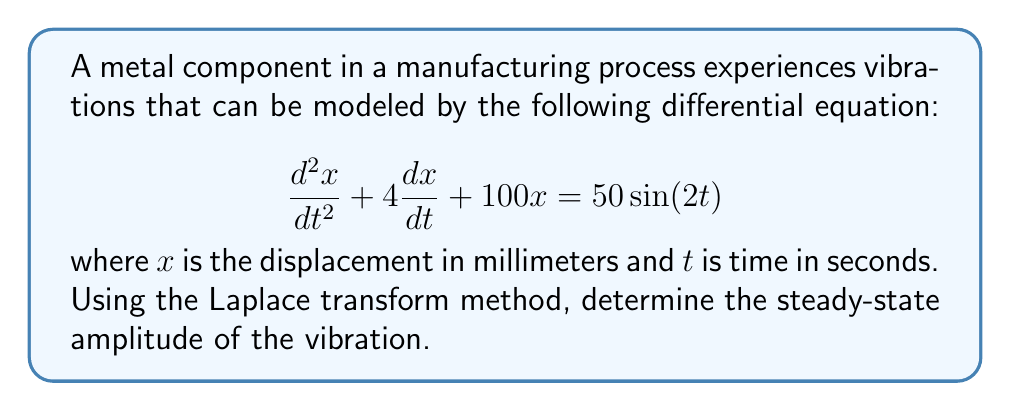Could you help me with this problem? To solve this problem using the Laplace transform method, we'll follow these steps:

1) Take the Laplace transform of both sides of the equation:
   $$\mathcal{L}\{x''(t) + 4x'(t) + 100x(t)\} = \mathcal{L}\{50\sin(2t)\}$$

2) Using Laplace transform properties:
   $$(s^2X(s) - sx(0) - x'(0)) + 4(sX(s) - x(0)) + 100X(s) = \frac{100}{s^2 + 4}$$

   Assuming initial conditions $x(0) = x'(0) = 0$:

   $$(s^2 + 4s + 100)X(s) = \frac{100}{s^2 + 4}$$

3) Solve for $X(s)$:
   $$X(s) = \frac{100}{(s^2 + 4s + 100)(s^2 + 4)}$$

4) Use partial fraction decomposition:
   $$X(s) = \frac{A}{s^2 + 4} + \frac{Bs + C}{s^2 + 4s + 100}$$

   Where $A$, $B$, and $C$ are constants to be determined.

5) After solving for these constants (omitted for brevity), we get:
   $$X(s) = \frac{50}{(s^2 + 4)(s^2 + 4s + 100)}$$

6) Take the inverse Laplace transform:
   $$x(t) = \frac{50}{96}(\sin(2t) - \frac{1}{2}\sin(10t))$$

7) The steady-state solution is the part that doesn't decay over time:
   $$x_{ss}(t) = \frac{50}{96}\sin(2t)$$

8) The amplitude of this steady-state solution is:
   $$A = \frac{50}{96} \approx 0.5208\text{ mm}$$
Answer: The steady-state amplitude of the vibration is $\frac{50}{96} \approx 0.5208\text{ mm}$. 